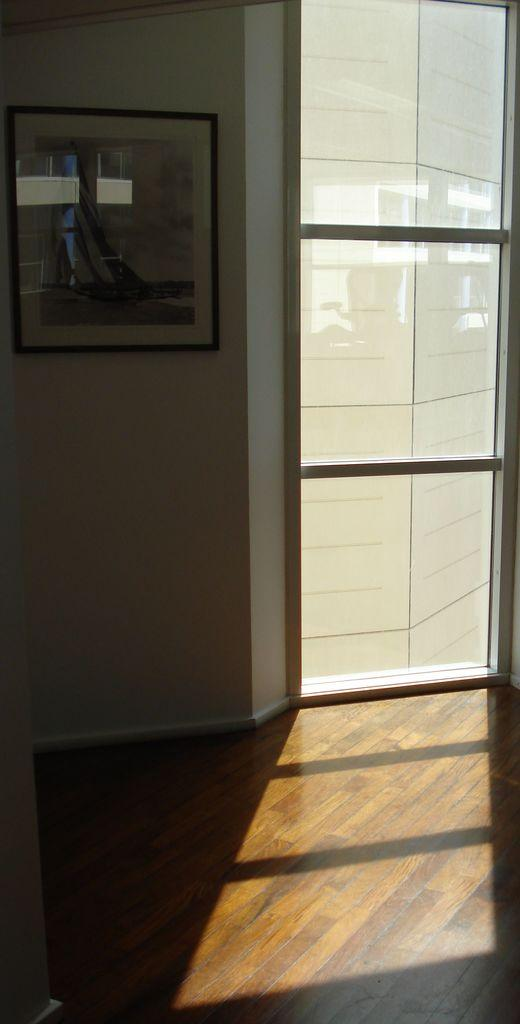What object is present in the image that typically holds a photograph? There is a photo frame in the image. Where is the photo frame located in relation to other objects? The photo frame is near a door. What can be seen through the door in the image? There is a building visible through the door. What type of flooring is present in the image? There is a wooden floor in the image. Are there any cacti visible in the image? No, there are no cacti present in the image. 